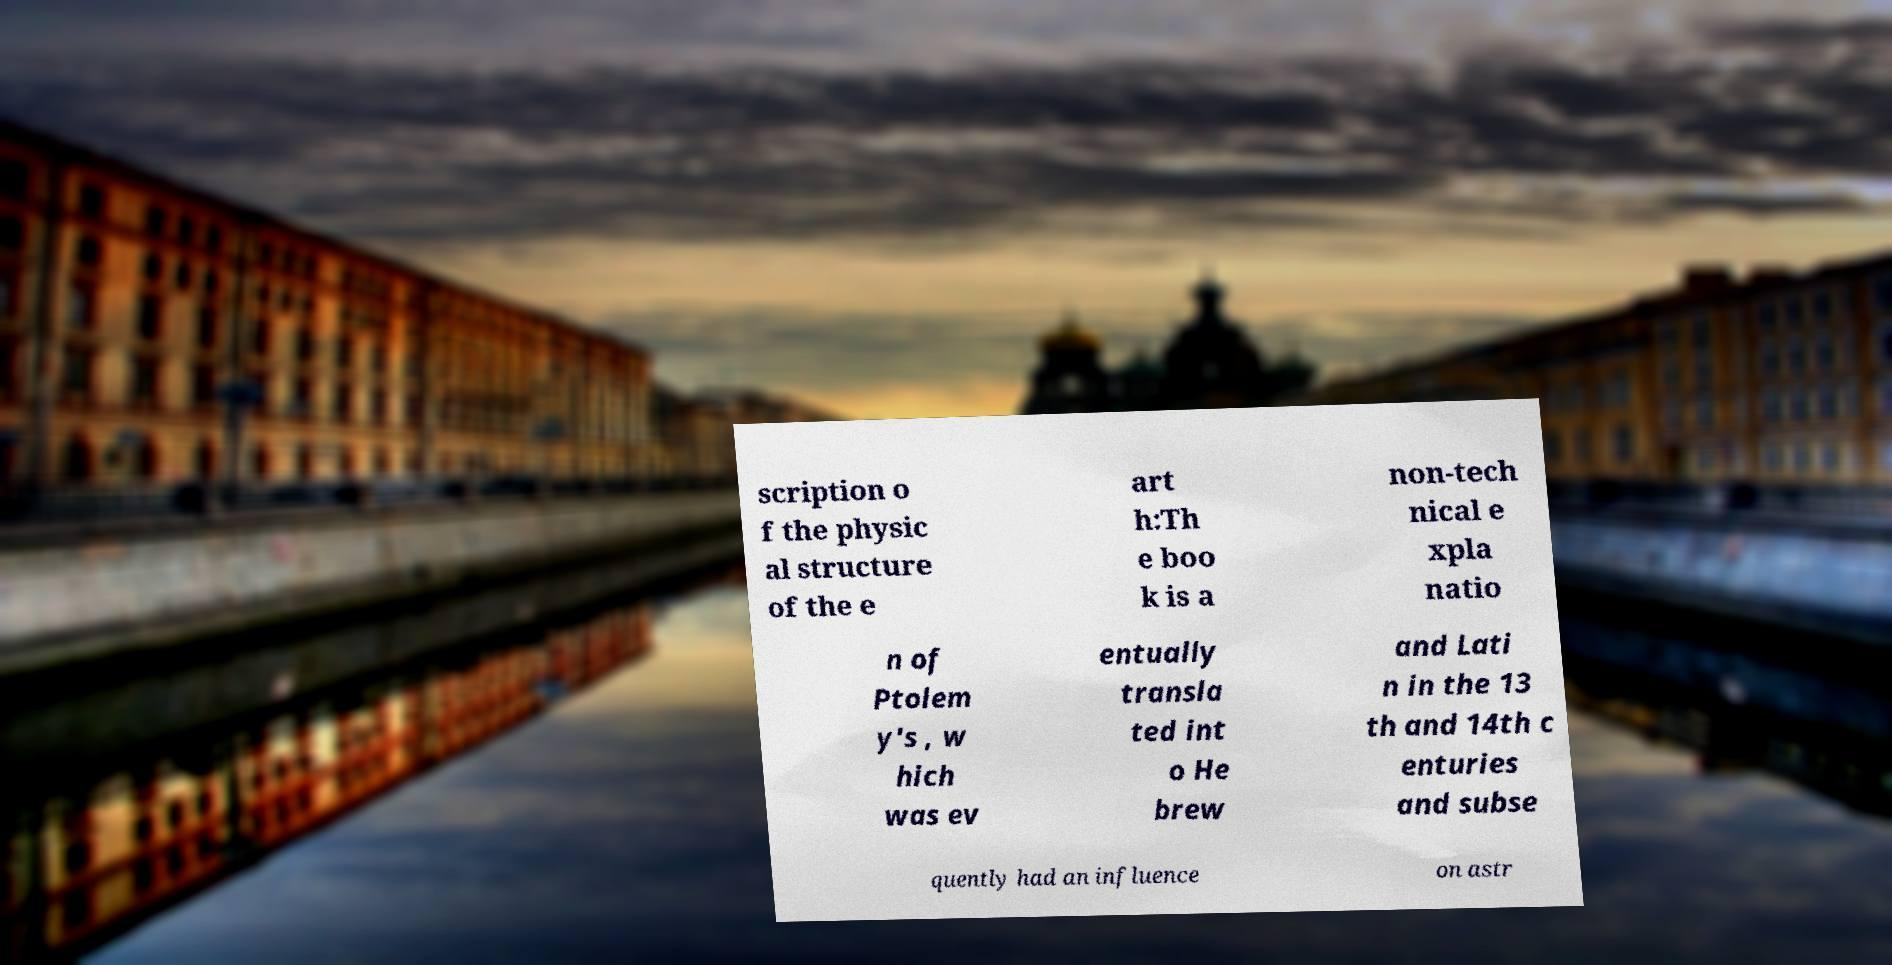Could you extract and type out the text from this image? scription o f the physic al structure of the e art h:Th e boo k is a non-tech nical e xpla natio n of Ptolem y's , w hich was ev entually transla ted int o He brew and Lati n in the 13 th and 14th c enturies and subse quently had an influence on astr 